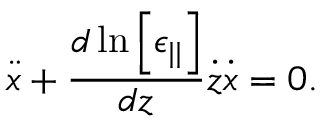<formula> <loc_0><loc_0><loc_500><loc_500>\ddot { x } + \frac { d \ln \left [ \epsilon _ { | | } \right ] } { d z } \dot { z } \dot { x } = 0 .</formula> 